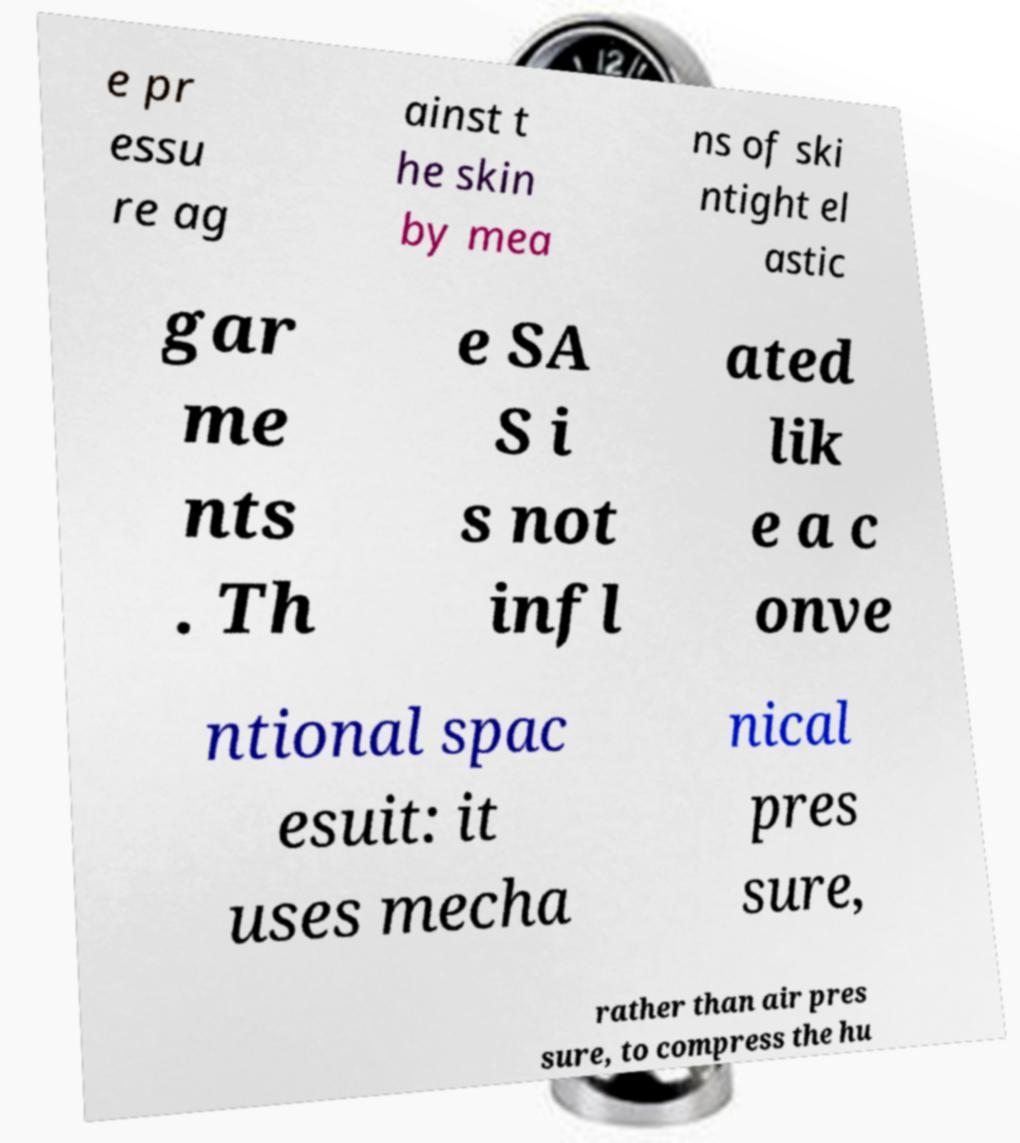Could you extract and type out the text from this image? e pr essu re ag ainst t he skin by mea ns of ski ntight el astic gar me nts . Th e SA S i s not infl ated lik e a c onve ntional spac esuit: it uses mecha nical pres sure, rather than air pres sure, to compress the hu 